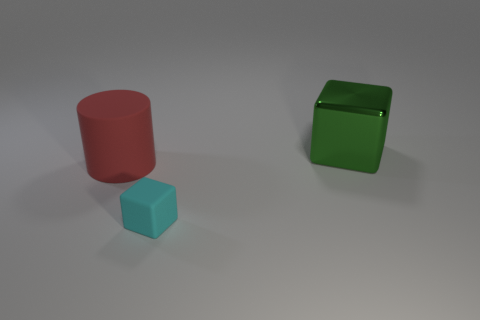There is a cube that is to the right of the block in front of the block behind the tiny cyan matte thing; what is its material?
Your response must be concise. Metal. Is there a red rubber ball that has the same size as the green metallic block?
Offer a terse response. No. There is a thing that is made of the same material as the red cylinder; what size is it?
Provide a short and direct response. Small. What is the shape of the red object?
Ensure brevity in your answer.  Cylinder. Does the cylinder have the same material as the block left of the green object?
Make the answer very short. Yes. How many objects are either cyan rubber blocks or tiny purple metal cylinders?
Your answer should be compact. 1. Are there any small red matte cylinders?
Offer a terse response. No. There is a rubber thing that is on the left side of the cube that is in front of the large block; what shape is it?
Ensure brevity in your answer.  Cylinder. What number of objects are either big things that are to the left of the cyan rubber thing or large metallic blocks behind the red matte thing?
Offer a very short reply. 2. What is the material of the other red thing that is the same size as the metal object?
Offer a very short reply. Rubber. 